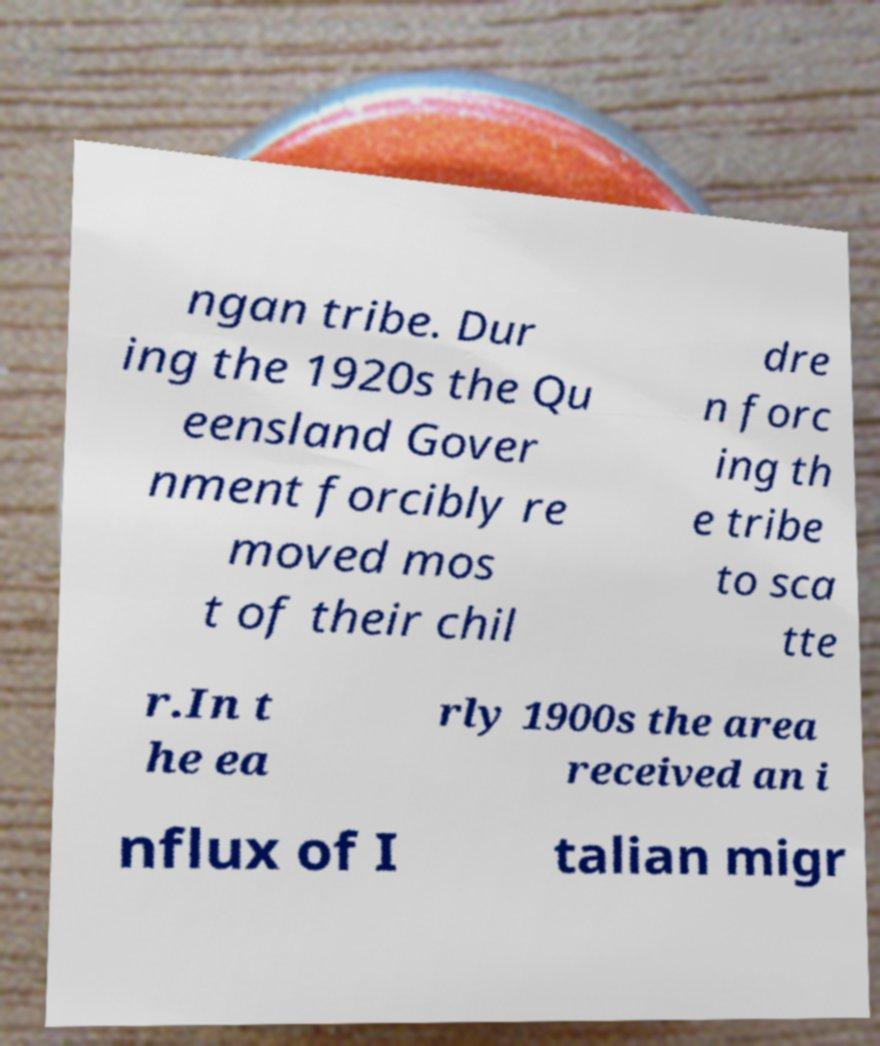What messages or text are displayed in this image? I need them in a readable, typed format. ngan tribe. Dur ing the 1920s the Qu eensland Gover nment forcibly re moved mos t of their chil dre n forc ing th e tribe to sca tte r.In t he ea rly 1900s the area received an i nflux of I talian migr 